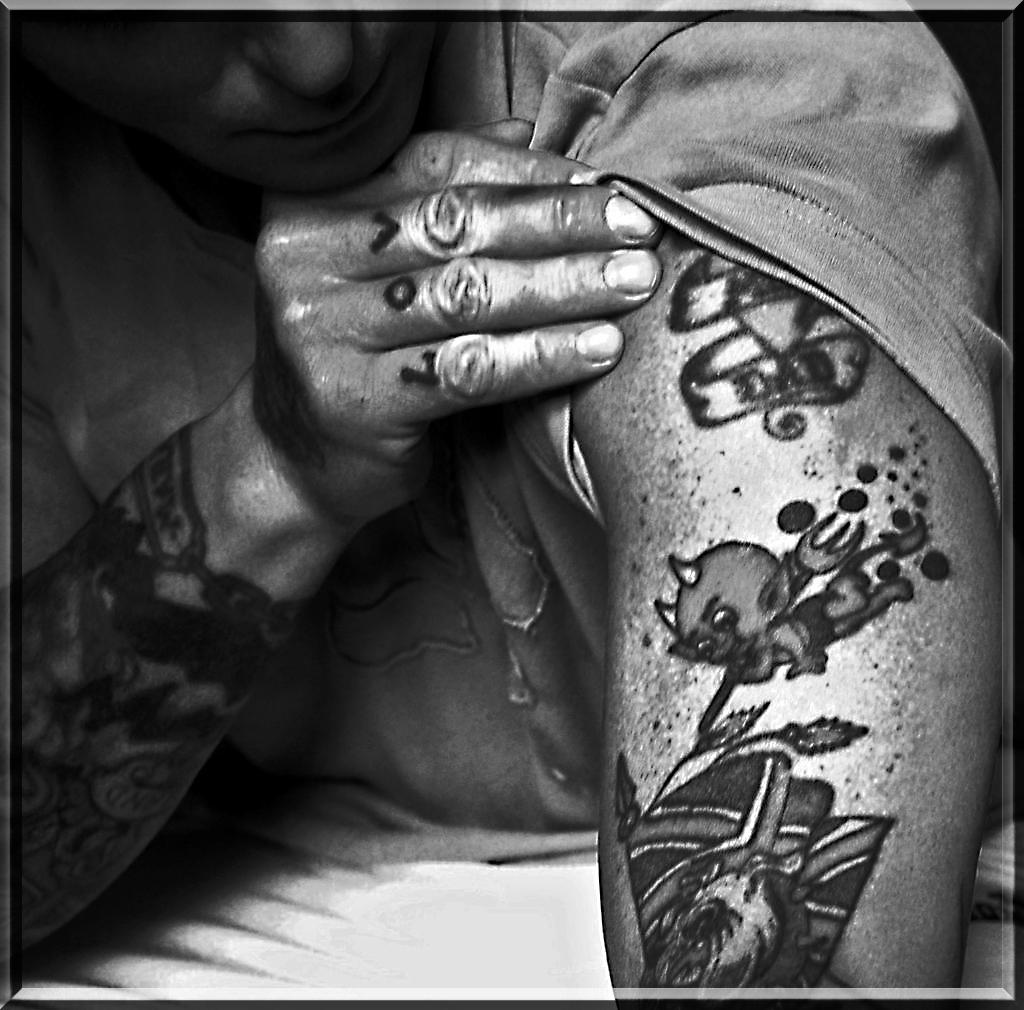What can be seen on the hands in the image? There are tattoos on the hands in the image. What is the color scheme of the image? The image is in black and white. What type of maid is depicted in the image? There is no maid present in the image; it only features tattoos on hands. How does the underwear appear in the image? There is no underwear present in the image. 